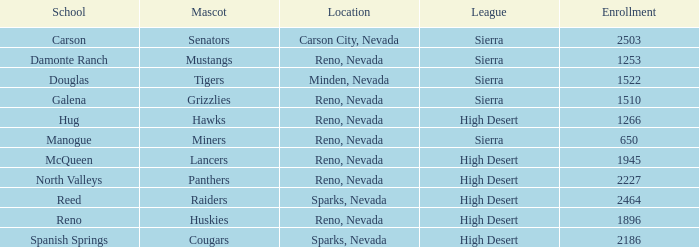Which leagues have Raiders as their mascot? High Desert. 